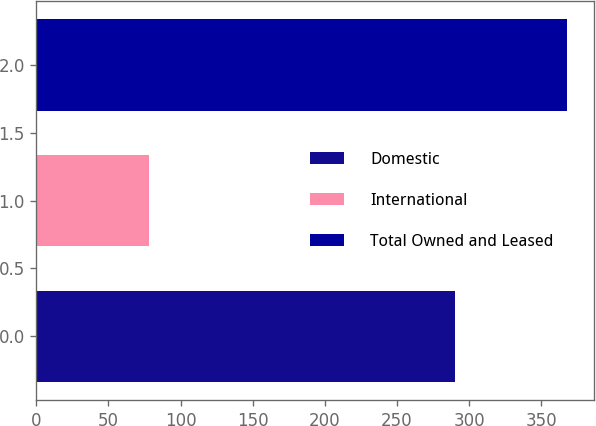Convert chart. <chart><loc_0><loc_0><loc_500><loc_500><bar_chart><fcel>Domestic<fcel>International<fcel>Total Owned and Leased<nl><fcel>290<fcel>78<fcel>368<nl></chart> 